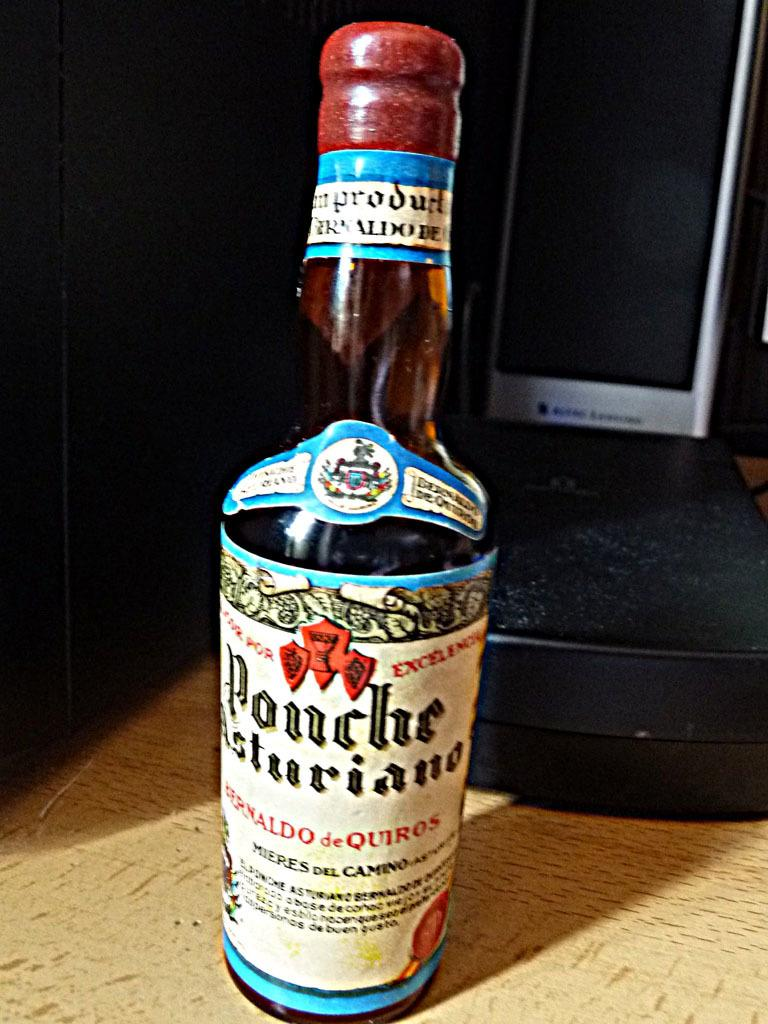<image>
Present a compact description of the photo's key features. a bottle of ponche liquor with a red top 